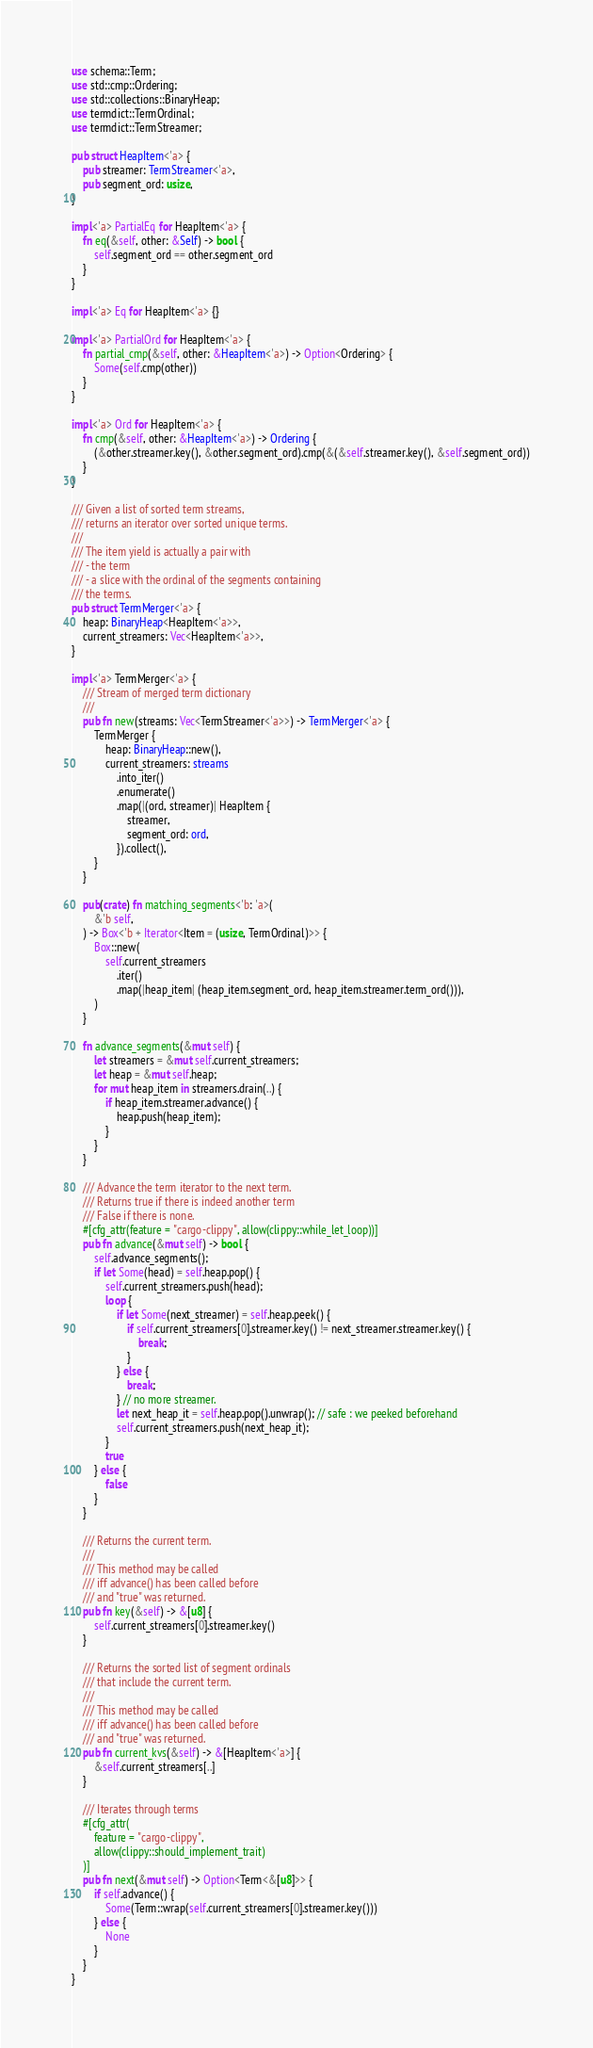Convert code to text. <code><loc_0><loc_0><loc_500><loc_500><_Rust_>use schema::Term;
use std::cmp::Ordering;
use std::collections::BinaryHeap;
use termdict::TermOrdinal;
use termdict::TermStreamer;

pub struct HeapItem<'a> {
    pub streamer: TermStreamer<'a>,
    pub segment_ord: usize,
}

impl<'a> PartialEq for HeapItem<'a> {
    fn eq(&self, other: &Self) -> bool {
        self.segment_ord == other.segment_ord
    }
}

impl<'a> Eq for HeapItem<'a> {}

impl<'a> PartialOrd for HeapItem<'a> {
    fn partial_cmp(&self, other: &HeapItem<'a>) -> Option<Ordering> {
        Some(self.cmp(other))
    }
}

impl<'a> Ord for HeapItem<'a> {
    fn cmp(&self, other: &HeapItem<'a>) -> Ordering {
        (&other.streamer.key(), &other.segment_ord).cmp(&(&self.streamer.key(), &self.segment_ord))
    }
}

/// Given a list of sorted term streams,
/// returns an iterator over sorted unique terms.
///
/// The item yield is actually a pair with
/// - the term
/// - a slice with the ordinal of the segments containing
/// the terms.
pub struct TermMerger<'a> {
    heap: BinaryHeap<HeapItem<'a>>,
    current_streamers: Vec<HeapItem<'a>>,
}

impl<'a> TermMerger<'a> {
    /// Stream of merged term dictionary
    ///
    pub fn new(streams: Vec<TermStreamer<'a>>) -> TermMerger<'a> {
        TermMerger {
            heap: BinaryHeap::new(),
            current_streamers: streams
                .into_iter()
                .enumerate()
                .map(|(ord, streamer)| HeapItem {
                    streamer,
                    segment_ord: ord,
                }).collect(),
        }
    }

    pub(crate) fn matching_segments<'b: 'a>(
        &'b self,
    ) -> Box<'b + Iterator<Item = (usize, TermOrdinal)>> {
        Box::new(
            self.current_streamers
                .iter()
                .map(|heap_item| (heap_item.segment_ord, heap_item.streamer.term_ord())),
        )
    }

    fn advance_segments(&mut self) {
        let streamers = &mut self.current_streamers;
        let heap = &mut self.heap;
        for mut heap_item in streamers.drain(..) {
            if heap_item.streamer.advance() {
                heap.push(heap_item);
            }
        }
    }

    /// Advance the term iterator to the next term.
    /// Returns true if there is indeed another term
    /// False if there is none.
    #[cfg_attr(feature = "cargo-clippy", allow(clippy::while_let_loop))]
    pub fn advance(&mut self) -> bool {
        self.advance_segments();
        if let Some(head) = self.heap.pop() {
            self.current_streamers.push(head);
            loop {
                if let Some(next_streamer) = self.heap.peek() {
                    if self.current_streamers[0].streamer.key() != next_streamer.streamer.key() {
                        break;
                    }
                } else {
                    break;
                } // no more streamer.
                let next_heap_it = self.heap.pop().unwrap(); // safe : we peeked beforehand
                self.current_streamers.push(next_heap_it);
            }
            true
        } else {
            false
        }
    }

    /// Returns the current term.
    ///
    /// This method may be called
    /// iff advance() has been called before
    /// and "true" was returned.
    pub fn key(&self) -> &[u8] {
        self.current_streamers[0].streamer.key()
    }

    /// Returns the sorted list of segment ordinals
    /// that include the current term.
    ///
    /// This method may be called
    /// iff advance() has been called before
    /// and "true" was returned.
    pub fn current_kvs(&self) -> &[HeapItem<'a>] {
        &self.current_streamers[..]
    }

    /// Iterates through terms
    #[cfg_attr(
        feature = "cargo-clippy",
        allow(clippy::should_implement_trait)
    )]
    pub fn next(&mut self) -> Option<Term<&[u8]>> {
        if self.advance() {
            Some(Term::wrap(self.current_streamers[0].streamer.key()))
        } else {
            None
        }
    }
}
</code> 